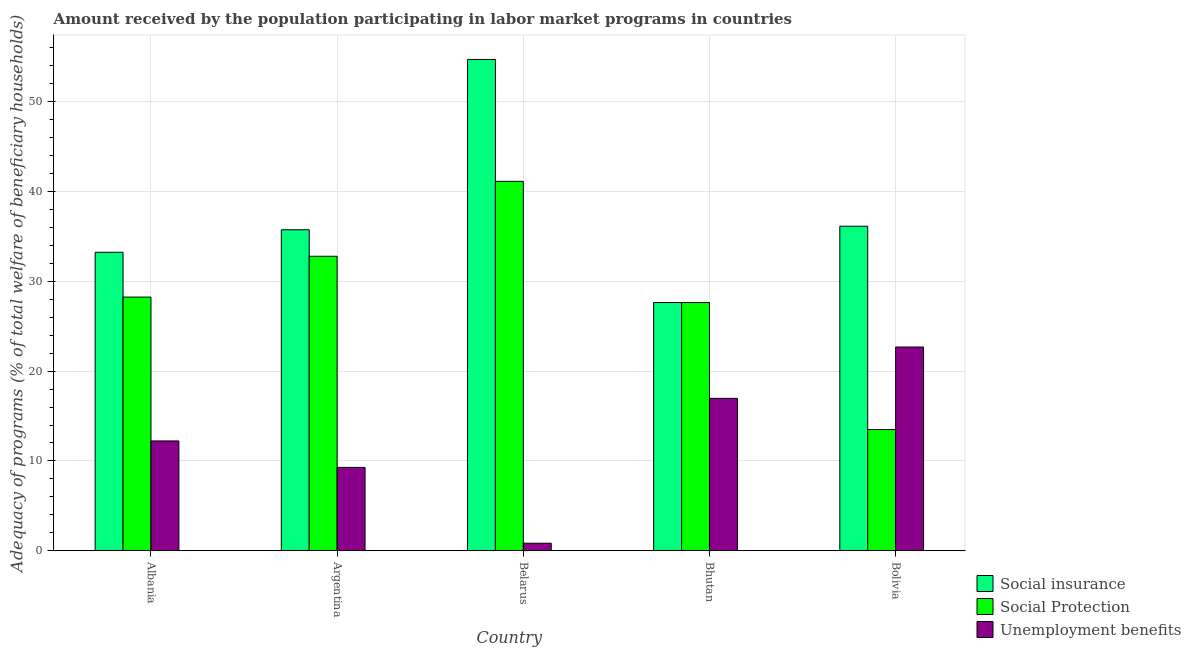How many groups of bars are there?
Your answer should be compact. 5. Are the number of bars per tick equal to the number of legend labels?
Your answer should be compact. Yes. In how many cases, is the number of bars for a given country not equal to the number of legend labels?
Your answer should be very brief. 0. What is the amount received by the population participating in social insurance programs in Albania?
Offer a very short reply. 33.23. Across all countries, what is the maximum amount received by the population participating in social insurance programs?
Ensure brevity in your answer.  54.7. Across all countries, what is the minimum amount received by the population participating in unemployment benefits programs?
Provide a succinct answer. 0.84. In which country was the amount received by the population participating in social insurance programs maximum?
Keep it short and to the point. Belarus. In which country was the amount received by the population participating in social protection programs minimum?
Offer a very short reply. Bolivia. What is the total amount received by the population participating in social protection programs in the graph?
Your response must be concise. 143.29. What is the difference between the amount received by the population participating in social insurance programs in Albania and that in Bolivia?
Make the answer very short. -2.9. What is the difference between the amount received by the population participating in social insurance programs in Argentina and the amount received by the population participating in unemployment benefits programs in Belarus?
Your response must be concise. 34.9. What is the average amount received by the population participating in social insurance programs per country?
Keep it short and to the point. 37.49. In how many countries, is the amount received by the population participating in unemployment benefits programs greater than 14 %?
Give a very brief answer. 2. What is the ratio of the amount received by the population participating in social protection programs in Belarus to that in Bolivia?
Offer a very short reply. 3.05. Is the difference between the amount received by the population participating in unemployment benefits programs in Belarus and Bhutan greater than the difference between the amount received by the population participating in social insurance programs in Belarus and Bhutan?
Offer a terse response. No. What is the difference between the highest and the second highest amount received by the population participating in social insurance programs?
Provide a short and direct response. 18.57. What is the difference between the highest and the lowest amount received by the population participating in unemployment benefits programs?
Provide a succinct answer. 21.84. What does the 1st bar from the left in Belarus represents?
Your response must be concise. Social insurance. What does the 1st bar from the right in Belarus represents?
Ensure brevity in your answer.  Unemployment benefits. How many bars are there?
Your answer should be compact. 15. What is the difference between two consecutive major ticks on the Y-axis?
Your response must be concise. 10. Does the graph contain any zero values?
Provide a short and direct response. No. How are the legend labels stacked?
Keep it short and to the point. Vertical. What is the title of the graph?
Your answer should be compact. Amount received by the population participating in labor market programs in countries. Does "Travel services" appear as one of the legend labels in the graph?
Your answer should be very brief. No. What is the label or title of the X-axis?
Give a very brief answer. Country. What is the label or title of the Y-axis?
Ensure brevity in your answer.  Adequacy of programs (% of total welfare of beneficiary households). What is the Adequacy of programs (% of total welfare of beneficiary households) of Social insurance in Albania?
Provide a short and direct response. 33.23. What is the Adequacy of programs (% of total welfare of beneficiary households) of Social Protection in Albania?
Provide a succinct answer. 28.24. What is the Adequacy of programs (% of total welfare of beneficiary households) in Unemployment benefits in Albania?
Your response must be concise. 12.23. What is the Adequacy of programs (% of total welfare of beneficiary households) in Social insurance in Argentina?
Provide a succinct answer. 35.74. What is the Adequacy of programs (% of total welfare of beneficiary households) of Social Protection in Argentina?
Provide a short and direct response. 32.79. What is the Adequacy of programs (% of total welfare of beneficiary households) of Unemployment benefits in Argentina?
Make the answer very short. 9.28. What is the Adequacy of programs (% of total welfare of beneficiary households) in Social insurance in Belarus?
Provide a short and direct response. 54.7. What is the Adequacy of programs (% of total welfare of beneficiary households) in Social Protection in Belarus?
Offer a very short reply. 41.13. What is the Adequacy of programs (% of total welfare of beneficiary households) of Unemployment benefits in Belarus?
Your answer should be very brief. 0.84. What is the Adequacy of programs (% of total welfare of beneficiary households) of Social insurance in Bhutan?
Offer a very short reply. 27.64. What is the Adequacy of programs (% of total welfare of beneficiary households) of Social Protection in Bhutan?
Make the answer very short. 27.64. What is the Adequacy of programs (% of total welfare of beneficiary households) of Unemployment benefits in Bhutan?
Keep it short and to the point. 16.97. What is the Adequacy of programs (% of total welfare of beneficiary households) in Social insurance in Bolivia?
Provide a short and direct response. 36.13. What is the Adequacy of programs (% of total welfare of beneficiary households) of Social Protection in Bolivia?
Give a very brief answer. 13.5. What is the Adequacy of programs (% of total welfare of beneficiary households) in Unemployment benefits in Bolivia?
Give a very brief answer. 22.68. Across all countries, what is the maximum Adequacy of programs (% of total welfare of beneficiary households) in Social insurance?
Your answer should be very brief. 54.7. Across all countries, what is the maximum Adequacy of programs (% of total welfare of beneficiary households) in Social Protection?
Offer a terse response. 41.13. Across all countries, what is the maximum Adequacy of programs (% of total welfare of beneficiary households) in Unemployment benefits?
Your answer should be compact. 22.68. Across all countries, what is the minimum Adequacy of programs (% of total welfare of beneficiary households) of Social insurance?
Make the answer very short. 27.64. Across all countries, what is the minimum Adequacy of programs (% of total welfare of beneficiary households) in Social Protection?
Offer a terse response. 13.5. Across all countries, what is the minimum Adequacy of programs (% of total welfare of beneficiary households) of Unemployment benefits?
Offer a very short reply. 0.84. What is the total Adequacy of programs (% of total welfare of beneficiary households) in Social insurance in the graph?
Keep it short and to the point. 187.44. What is the total Adequacy of programs (% of total welfare of beneficiary households) of Social Protection in the graph?
Offer a very short reply. 143.29. What is the total Adequacy of programs (% of total welfare of beneficiary households) in Unemployment benefits in the graph?
Make the answer very short. 62. What is the difference between the Adequacy of programs (% of total welfare of beneficiary households) of Social insurance in Albania and that in Argentina?
Give a very brief answer. -2.51. What is the difference between the Adequacy of programs (% of total welfare of beneficiary households) in Social Protection in Albania and that in Argentina?
Your response must be concise. -4.54. What is the difference between the Adequacy of programs (% of total welfare of beneficiary households) in Unemployment benefits in Albania and that in Argentina?
Offer a very short reply. 2.95. What is the difference between the Adequacy of programs (% of total welfare of beneficiary households) in Social insurance in Albania and that in Belarus?
Keep it short and to the point. -21.47. What is the difference between the Adequacy of programs (% of total welfare of beneficiary households) of Social Protection in Albania and that in Belarus?
Provide a short and direct response. -12.89. What is the difference between the Adequacy of programs (% of total welfare of beneficiary households) in Unemployment benefits in Albania and that in Belarus?
Your response must be concise. 11.39. What is the difference between the Adequacy of programs (% of total welfare of beneficiary households) in Social insurance in Albania and that in Bhutan?
Your answer should be very brief. 5.6. What is the difference between the Adequacy of programs (% of total welfare of beneficiary households) of Social Protection in Albania and that in Bhutan?
Your response must be concise. 0.61. What is the difference between the Adequacy of programs (% of total welfare of beneficiary households) in Unemployment benefits in Albania and that in Bhutan?
Your response must be concise. -4.74. What is the difference between the Adequacy of programs (% of total welfare of beneficiary households) in Social insurance in Albania and that in Bolivia?
Your response must be concise. -2.9. What is the difference between the Adequacy of programs (% of total welfare of beneficiary households) of Social Protection in Albania and that in Bolivia?
Make the answer very short. 14.75. What is the difference between the Adequacy of programs (% of total welfare of beneficiary households) in Unemployment benefits in Albania and that in Bolivia?
Offer a terse response. -10.46. What is the difference between the Adequacy of programs (% of total welfare of beneficiary households) in Social insurance in Argentina and that in Belarus?
Your answer should be compact. -18.96. What is the difference between the Adequacy of programs (% of total welfare of beneficiary households) in Social Protection in Argentina and that in Belarus?
Ensure brevity in your answer.  -8.34. What is the difference between the Adequacy of programs (% of total welfare of beneficiary households) in Unemployment benefits in Argentina and that in Belarus?
Your response must be concise. 8.44. What is the difference between the Adequacy of programs (% of total welfare of beneficiary households) of Social insurance in Argentina and that in Bhutan?
Offer a terse response. 8.1. What is the difference between the Adequacy of programs (% of total welfare of beneficiary households) in Social Protection in Argentina and that in Bhutan?
Provide a succinct answer. 5.15. What is the difference between the Adequacy of programs (% of total welfare of beneficiary households) of Unemployment benefits in Argentina and that in Bhutan?
Provide a short and direct response. -7.69. What is the difference between the Adequacy of programs (% of total welfare of beneficiary households) of Social insurance in Argentina and that in Bolivia?
Your response must be concise. -0.39. What is the difference between the Adequacy of programs (% of total welfare of beneficiary households) in Social Protection in Argentina and that in Bolivia?
Your answer should be very brief. 19.29. What is the difference between the Adequacy of programs (% of total welfare of beneficiary households) in Unemployment benefits in Argentina and that in Bolivia?
Your answer should be compact. -13.4. What is the difference between the Adequacy of programs (% of total welfare of beneficiary households) in Social insurance in Belarus and that in Bhutan?
Provide a short and direct response. 27.06. What is the difference between the Adequacy of programs (% of total welfare of beneficiary households) in Social Protection in Belarus and that in Bhutan?
Offer a very short reply. 13.49. What is the difference between the Adequacy of programs (% of total welfare of beneficiary households) of Unemployment benefits in Belarus and that in Bhutan?
Make the answer very short. -16.13. What is the difference between the Adequacy of programs (% of total welfare of beneficiary households) of Social insurance in Belarus and that in Bolivia?
Provide a succinct answer. 18.57. What is the difference between the Adequacy of programs (% of total welfare of beneficiary households) of Social Protection in Belarus and that in Bolivia?
Offer a terse response. 27.63. What is the difference between the Adequacy of programs (% of total welfare of beneficiary households) of Unemployment benefits in Belarus and that in Bolivia?
Make the answer very short. -21.84. What is the difference between the Adequacy of programs (% of total welfare of beneficiary households) of Social insurance in Bhutan and that in Bolivia?
Keep it short and to the point. -8.5. What is the difference between the Adequacy of programs (% of total welfare of beneficiary households) in Social Protection in Bhutan and that in Bolivia?
Provide a succinct answer. 14.14. What is the difference between the Adequacy of programs (% of total welfare of beneficiary households) in Unemployment benefits in Bhutan and that in Bolivia?
Keep it short and to the point. -5.71. What is the difference between the Adequacy of programs (% of total welfare of beneficiary households) in Social insurance in Albania and the Adequacy of programs (% of total welfare of beneficiary households) in Social Protection in Argentina?
Offer a very short reply. 0.45. What is the difference between the Adequacy of programs (% of total welfare of beneficiary households) of Social insurance in Albania and the Adequacy of programs (% of total welfare of beneficiary households) of Unemployment benefits in Argentina?
Offer a very short reply. 23.95. What is the difference between the Adequacy of programs (% of total welfare of beneficiary households) of Social Protection in Albania and the Adequacy of programs (% of total welfare of beneficiary households) of Unemployment benefits in Argentina?
Offer a terse response. 18.96. What is the difference between the Adequacy of programs (% of total welfare of beneficiary households) of Social insurance in Albania and the Adequacy of programs (% of total welfare of beneficiary households) of Social Protection in Belarus?
Offer a very short reply. -7.9. What is the difference between the Adequacy of programs (% of total welfare of beneficiary households) of Social insurance in Albania and the Adequacy of programs (% of total welfare of beneficiary households) of Unemployment benefits in Belarus?
Offer a terse response. 32.39. What is the difference between the Adequacy of programs (% of total welfare of beneficiary households) of Social Protection in Albania and the Adequacy of programs (% of total welfare of beneficiary households) of Unemployment benefits in Belarus?
Ensure brevity in your answer.  27.4. What is the difference between the Adequacy of programs (% of total welfare of beneficiary households) in Social insurance in Albania and the Adequacy of programs (% of total welfare of beneficiary households) in Social Protection in Bhutan?
Keep it short and to the point. 5.6. What is the difference between the Adequacy of programs (% of total welfare of beneficiary households) in Social insurance in Albania and the Adequacy of programs (% of total welfare of beneficiary households) in Unemployment benefits in Bhutan?
Offer a terse response. 16.26. What is the difference between the Adequacy of programs (% of total welfare of beneficiary households) of Social Protection in Albania and the Adequacy of programs (% of total welfare of beneficiary households) of Unemployment benefits in Bhutan?
Keep it short and to the point. 11.28. What is the difference between the Adequacy of programs (% of total welfare of beneficiary households) of Social insurance in Albania and the Adequacy of programs (% of total welfare of beneficiary households) of Social Protection in Bolivia?
Your answer should be very brief. 19.73. What is the difference between the Adequacy of programs (% of total welfare of beneficiary households) in Social insurance in Albania and the Adequacy of programs (% of total welfare of beneficiary households) in Unemployment benefits in Bolivia?
Ensure brevity in your answer.  10.55. What is the difference between the Adequacy of programs (% of total welfare of beneficiary households) in Social Protection in Albania and the Adequacy of programs (% of total welfare of beneficiary households) in Unemployment benefits in Bolivia?
Provide a short and direct response. 5.56. What is the difference between the Adequacy of programs (% of total welfare of beneficiary households) of Social insurance in Argentina and the Adequacy of programs (% of total welfare of beneficiary households) of Social Protection in Belarus?
Provide a short and direct response. -5.39. What is the difference between the Adequacy of programs (% of total welfare of beneficiary households) of Social insurance in Argentina and the Adequacy of programs (% of total welfare of beneficiary households) of Unemployment benefits in Belarus?
Your answer should be very brief. 34.9. What is the difference between the Adequacy of programs (% of total welfare of beneficiary households) of Social Protection in Argentina and the Adequacy of programs (% of total welfare of beneficiary households) of Unemployment benefits in Belarus?
Your answer should be very brief. 31.95. What is the difference between the Adequacy of programs (% of total welfare of beneficiary households) of Social insurance in Argentina and the Adequacy of programs (% of total welfare of beneficiary households) of Social Protection in Bhutan?
Provide a succinct answer. 8.1. What is the difference between the Adequacy of programs (% of total welfare of beneficiary households) of Social insurance in Argentina and the Adequacy of programs (% of total welfare of beneficiary households) of Unemployment benefits in Bhutan?
Your response must be concise. 18.77. What is the difference between the Adequacy of programs (% of total welfare of beneficiary households) in Social Protection in Argentina and the Adequacy of programs (% of total welfare of beneficiary households) in Unemployment benefits in Bhutan?
Keep it short and to the point. 15.82. What is the difference between the Adequacy of programs (% of total welfare of beneficiary households) of Social insurance in Argentina and the Adequacy of programs (% of total welfare of beneficiary households) of Social Protection in Bolivia?
Offer a terse response. 22.24. What is the difference between the Adequacy of programs (% of total welfare of beneficiary households) of Social insurance in Argentina and the Adequacy of programs (% of total welfare of beneficiary households) of Unemployment benefits in Bolivia?
Your answer should be compact. 13.06. What is the difference between the Adequacy of programs (% of total welfare of beneficiary households) of Social Protection in Argentina and the Adequacy of programs (% of total welfare of beneficiary households) of Unemployment benefits in Bolivia?
Provide a succinct answer. 10.1. What is the difference between the Adequacy of programs (% of total welfare of beneficiary households) of Social insurance in Belarus and the Adequacy of programs (% of total welfare of beneficiary households) of Social Protection in Bhutan?
Provide a short and direct response. 27.06. What is the difference between the Adequacy of programs (% of total welfare of beneficiary households) in Social insurance in Belarus and the Adequacy of programs (% of total welfare of beneficiary households) in Unemployment benefits in Bhutan?
Offer a terse response. 37.73. What is the difference between the Adequacy of programs (% of total welfare of beneficiary households) in Social Protection in Belarus and the Adequacy of programs (% of total welfare of beneficiary households) in Unemployment benefits in Bhutan?
Provide a succinct answer. 24.16. What is the difference between the Adequacy of programs (% of total welfare of beneficiary households) of Social insurance in Belarus and the Adequacy of programs (% of total welfare of beneficiary households) of Social Protection in Bolivia?
Offer a terse response. 41.2. What is the difference between the Adequacy of programs (% of total welfare of beneficiary households) of Social insurance in Belarus and the Adequacy of programs (% of total welfare of beneficiary households) of Unemployment benefits in Bolivia?
Your answer should be compact. 32.02. What is the difference between the Adequacy of programs (% of total welfare of beneficiary households) in Social Protection in Belarus and the Adequacy of programs (% of total welfare of beneficiary households) in Unemployment benefits in Bolivia?
Offer a very short reply. 18.45. What is the difference between the Adequacy of programs (% of total welfare of beneficiary households) of Social insurance in Bhutan and the Adequacy of programs (% of total welfare of beneficiary households) of Social Protection in Bolivia?
Provide a short and direct response. 14.14. What is the difference between the Adequacy of programs (% of total welfare of beneficiary households) in Social insurance in Bhutan and the Adequacy of programs (% of total welfare of beneficiary households) in Unemployment benefits in Bolivia?
Offer a terse response. 4.95. What is the difference between the Adequacy of programs (% of total welfare of beneficiary households) in Social Protection in Bhutan and the Adequacy of programs (% of total welfare of beneficiary households) in Unemployment benefits in Bolivia?
Provide a succinct answer. 4.95. What is the average Adequacy of programs (% of total welfare of beneficiary households) in Social insurance per country?
Your answer should be compact. 37.49. What is the average Adequacy of programs (% of total welfare of beneficiary households) in Social Protection per country?
Your answer should be compact. 28.66. What is the average Adequacy of programs (% of total welfare of beneficiary households) of Unemployment benefits per country?
Offer a terse response. 12.4. What is the difference between the Adequacy of programs (% of total welfare of beneficiary households) in Social insurance and Adequacy of programs (% of total welfare of beneficiary households) in Social Protection in Albania?
Ensure brevity in your answer.  4.99. What is the difference between the Adequacy of programs (% of total welfare of beneficiary households) of Social insurance and Adequacy of programs (% of total welfare of beneficiary households) of Unemployment benefits in Albania?
Keep it short and to the point. 21.01. What is the difference between the Adequacy of programs (% of total welfare of beneficiary households) in Social Protection and Adequacy of programs (% of total welfare of beneficiary households) in Unemployment benefits in Albania?
Offer a terse response. 16.02. What is the difference between the Adequacy of programs (% of total welfare of beneficiary households) of Social insurance and Adequacy of programs (% of total welfare of beneficiary households) of Social Protection in Argentina?
Your answer should be very brief. 2.95. What is the difference between the Adequacy of programs (% of total welfare of beneficiary households) in Social insurance and Adequacy of programs (% of total welfare of beneficiary households) in Unemployment benefits in Argentina?
Offer a terse response. 26.46. What is the difference between the Adequacy of programs (% of total welfare of beneficiary households) of Social Protection and Adequacy of programs (% of total welfare of beneficiary households) of Unemployment benefits in Argentina?
Provide a short and direct response. 23.5. What is the difference between the Adequacy of programs (% of total welfare of beneficiary households) of Social insurance and Adequacy of programs (% of total welfare of beneficiary households) of Social Protection in Belarus?
Your response must be concise. 13.57. What is the difference between the Adequacy of programs (% of total welfare of beneficiary households) of Social insurance and Adequacy of programs (% of total welfare of beneficiary households) of Unemployment benefits in Belarus?
Provide a short and direct response. 53.86. What is the difference between the Adequacy of programs (% of total welfare of beneficiary households) in Social Protection and Adequacy of programs (% of total welfare of beneficiary households) in Unemployment benefits in Belarus?
Your response must be concise. 40.29. What is the difference between the Adequacy of programs (% of total welfare of beneficiary households) in Social insurance and Adequacy of programs (% of total welfare of beneficiary households) in Unemployment benefits in Bhutan?
Give a very brief answer. 10.67. What is the difference between the Adequacy of programs (% of total welfare of beneficiary households) in Social Protection and Adequacy of programs (% of total welfare of beneficiary households) in Unemployment benefits in Bhutan?
Your answer should be very brief. 10.67. What is the difference between the Adequacy of programs (% of total welfare of beneficiary households) in Social insurance and Adequacy of programs (% of total welfare of beneficiary households) in Social Protection in Bolivia?
Offer a terse response. 22.64. What is the difference between the Adequacy of programs (% of total welfare of beneficiary households) of Social insurance and Adequacy of programs (% of total welfare of beneficiary households) of Unemployment benefits in Bolivia?
Keep it short and to the point. 13.45. What is the difference between the Adequacy of programs (% of total welfare of beneficiary households) of Social Protection and Adequacy of programs (% of total welfare of beneficiary households) of Unemployment benefits in Bolivia?
Make the answer very short. -9.19. What is the ratio of the Adequacy of programs (% of total welfare of beneficiary households) in Social insurance in Albania to that in Argentina?
Provide a short and direct response. 0.93. What is the ratio of the Adequacy of programs (% of total welfare of beneficiary households) in Social Protection in Albania to that in Argentina?
Your answer should be compact. 0.86. What is the ratio of the Adequacy of programs (% of total welfare of beneficiary households) of Unemployment benefits in Albania to that in Argentina?
Provide a short and direct response. 1.32. What is the ratio of the Adequacy of programs (% of total welfare of beneficiary households) in Social insurance in Albania to that in Belarus?
Provide a succinct answer. 0.61. What is the ratio of the Adequacy of programs (% of total welfare of beneficiary households) of Social Protection in Albania to that in Belarus?
Your response must be concise. 0.69. What is the ratio of the Adequacy of programs (% of total welfare of beneficiary households) in Unemployment benefits in Albania to that in Belarus?
Make the answer very short. 14.53. What is the ratio of the Adequacy of programs (% of total welfare of beneficiary households) in Social insurance in Albania to that in Bhutan?
Your answer should be compact. 1.2. What is the ratio of the Adequacy of programs (% of total welfare of beneficiary households) in Unemployment benefits in Albania to that in Bhutan?
Make the answer very short. 0.72. What is the ratio of the Adequacy of programs (% of total welfare of beneficiary households) of Social insurance in Albania to that in Bolivia?
Keep it short and to the point. 0.92. What is the ratio of the Adequacy of programs (% of total welfare of beneficiary households) of Social Protection in Albania to that in Bolivia?
Give a very brief answer. 2.09. What is the ratio of the Adequacy of programs (% of total welfare of beneficiary households) in Unemployment benefits in Albania to that in Bolivia?
Provide a short and direct response. 0.54. What is the ratio of the Adequacy of programs (% of total welfare of beneficiary households) of Social insurance in Argentina to that in Belarus?
Provide a succinct answer. 0.65. What is the ratio of the Adequacy of programs (% of total welfare of beneficiary households) of Social Protection in Argentina to that in Belarus?
Make the answer very short. 0.8. What is the ratio of the Adequacy of programs (% of total welfare of beneficiary households) of Unemployment benefits in Argentina to that in Belarus?
Keep it short and to the point. 11.03. What is the ratio of the Adequacy of programs (% of total welfare of beneficiary households) in Social insurance in Argentina to that in Bhutan?
Provide a short and direct response. 1.29. What is the ratio of the Adequacy of programs (% of total welfare of beneficiary households) in Social Protection in Argentina to that in Bhutan?
Make the answer very short. 1.19. What is the ratio of the Adequacy of programs (% of total welfare of beneficiary households) of Unemployment benefits in Argentina to that in Bhutan?
Provide a short and direct response. 0.55. What is the ratio of the Adequacy of programs (% of total welfare of beneficiary households) of Social Protection in Argentina to that in Bolivia?
Make the answer very short. 2.43. What is the ratio of the Adequacy of programs (% of total welfare of beneficiary households) in Unemployment benefits in Argentina to that in Bolivia?
Your response must be concise. 0.41. What is the ratio of the Adequacy of programs (% of total welfare of beneficiary households) of Social insurance in Belarus to that in Bhutan?
Give a very brief answer. 1.98. What is the ratio of the Adequacy of programs (% of total welfare of beneficiary households) of Social Protection in Belarus to that in Bhutan?
Offer a very short reply. 1.49. What is the ratio of the Adequacy of programs (% of total welfare of beneficiary households) of Unemployment benefits in Belarus to that in Bhutan?
Your answer should be compact. 0.05. What is the ratio of the Adequacy of programs (% of total welfare of beneficiary households) in Social insurance in Belarus to that in Bolivia?
Your answer should be compact. 1.51. What is the ratio of the Adequacy of programs (% of total welfare of beneficiary households) in Social Protection in Belarus to that in Bolivia?
Make the answer very short. 3.05. What is the ratio of the Adequacy of programs (% of total welfare of beneficiary households) in Unemployment benefits in Belarus to that in Bolivia?
Keep it short and to the point. 0.04. What is the ratio of the Adequacy of programs (% of total welfare of beneficiary households) of Social insurance in Bhutan to that in Bolivia?
Provide a short and direct response. 0.76. What is the ratio of the Adequacy of programs (% of total welfare of beneficiary households) of Social Protection in Bhutan to that in Bolivia?
Give a very brief answer. 2.05. What is the ratio of the Adequacy of programs (% of total welfare of beneficiary households) in Unemployment benefits in Bhutan to that in Bolivia?
Provide a short and direct response. 0.75. What is the difference between the highest and the second highest Adequacy of programs (% of total welfare of beneficiary households) in Social insurance?
Provide a short and direct response. 18.57. What is the difference between the highest and the second highest Adequacy of programs (% of total welfare of beneficiary households) in Social Protection?
Keep it short and to the point. 8.34. What is the difference between the highest and the second highest Adequacy of programs (% of total welfare of beneficiary households) of Unemployment benefits?
Your answer should be very brief. 5.71. What is the difference between the highest and the lowest Adequacy of programs (% of total welfare of beneficiary households) of Social insurance?
Your answer should be very brief. 27.06. What is the difference between the highest and the lowest Adequacy of programs (% of total welfare of beneficiary households) of Social Protection?
Your response must be concise. 27.63. What is the difference between the highest and the lowest Adequacy of programs (% of total welfare of beneficiary households) in Unemployment benefits?
Offer a terse response. 21.84. 